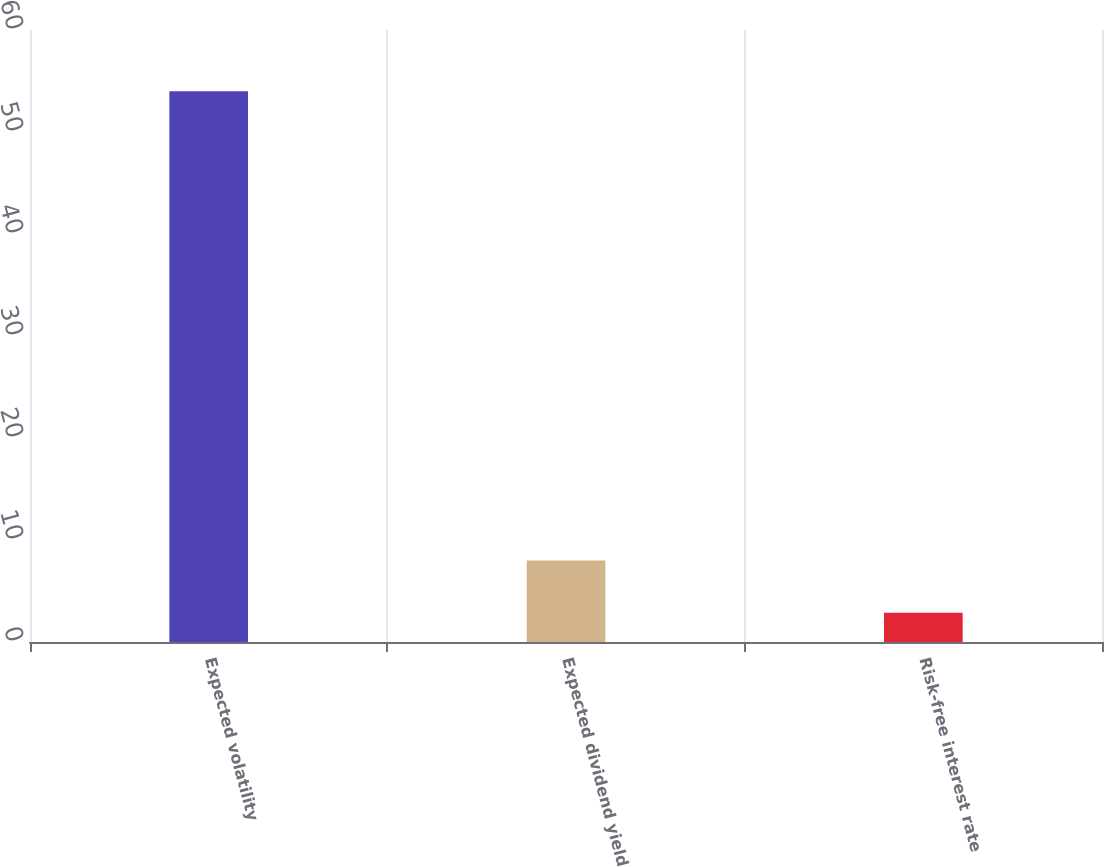Convert chart. <chart><loc_0><loc_0><loc_500><loc_500><bar_chart><fcel>Expected volatility<fcel>Expected dividend yield<fcel>Risk-free interest rate<nl><fcel>54<fcel>7.98<fcel>2.87<nl></chart> 